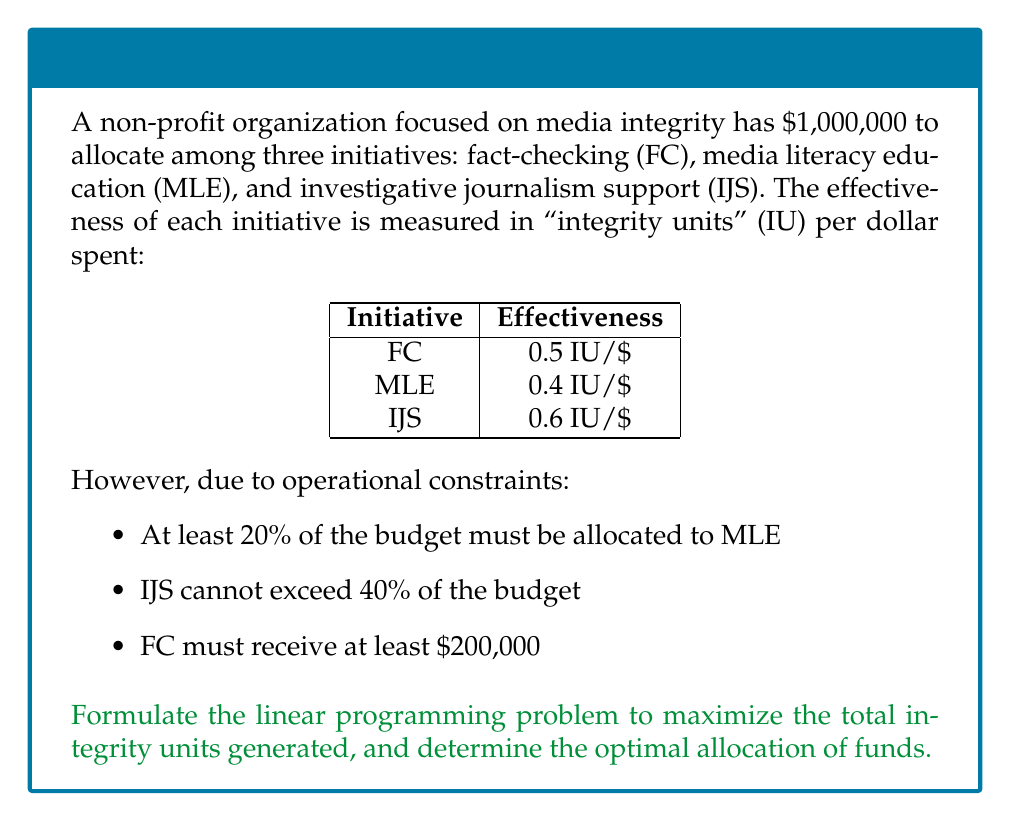Can you answer this question? Let's approach this step-by-step:

1) Define variables:
   Let $x_1$, $x_2$, and $x_3$ represent the amount allocated to FC, MLE, and IJS respectively.

2) Objective function:
   Maximize $Z = 0.5x_1 + 0.4x_2 + 0.6x_3$

3) Constraints:
   a) Total budget: $x_1 + x_2 + x_3 = 1,000,000$
   b) MLE at least 20%: $x_2 \geq 0.2(1,000,000) = 200,000$
   c) IJS at most 40%: $x_3 \leq 0.4(1,000,000) = 400,000$
   d) FC at least $200,000: $x_1 \geq 200,000$
   e) Non-negativity: $x_1, x_2, x_3 \geq 0$

4) Solve using the simplex method or linear programming software:

   The optimal solution is:
   $x_1 = 400,000$
   $x_2 = 200,000$
   $x_3 = 400,000$

5) Calculate the maximum integrity units:
   $Z = 0.5(400,000) + 0.4(200,000) + 0.6(400,000) = 520,000$ IU

Therefore, the optimal allocation is $400,000 to fact-checking, $200,000 to media literacy education, and $400,000 to investigative journalism support, generating a total of 520,000 integrity units.
Answer: FC: $400,000, MLE: $200,000, IJS: $400,000; Total: 520,000 IU 